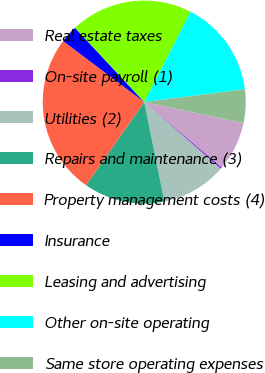Convert chart. <chart><loc_0><loc_0><loc_500><loc_500><pie_chart><fcel>Real estate taxes<fcel>On-site payroll (1)<fcel>Utilities (2)<fcel>Repairs and maintenance (3)<fcel>Property management costs (4)<fcel>Insurance<fcel>Leasing and advertising<fcel>Other on-site operating<fcel>Same store operating expenses<nl><fcel>7.85%<fcel>0.27%<fcel>10.38%<fcel>12.9%<fcel>25.54%<fcel>2.8%<fcel>19.49%<fcel>15.43%<fcel>5.33%<nl></chart> 